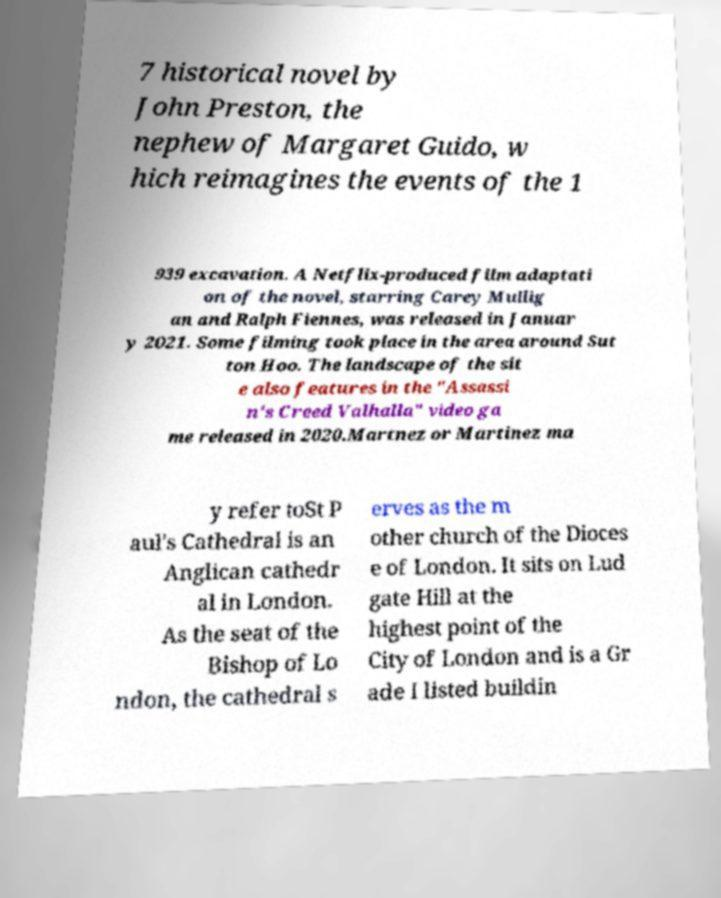Could you assist in decoding the text presented in this image and type it out clearly? 7 historical novel by John Preston, the nephew of Margaret Guido, w hich reimagines the events of the 1 939 excavation. A Netflix-produced film adaptati on of the novel, starring Carey Mullig an and Ralph Fiennes, was released in Januar y 2021. Some filming took place in the area around Sut ton Hoo. The landscape of the sit e also features in the "Assassi n's Creed Valhalla" video ga me released in 2020.Martnez or Martinez ma y refer toSt P aul's Cathedral is an Anglican cathedr al in London. As the seat of the Bishop of Lo ndon, the cathedral s erves as the m other church of the Dioces e of London. It sits on Lud gate Hill at the highest point of the City of London and is a Gr ade I listed buildin 